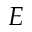Convert formula to latex. <formula><loc_0><loc_0><loc_500><loc_500>E</formula> 